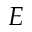Convert formula to latex. <formula><loc_0><loc_0><loc_500><loc_500>E</formula> 